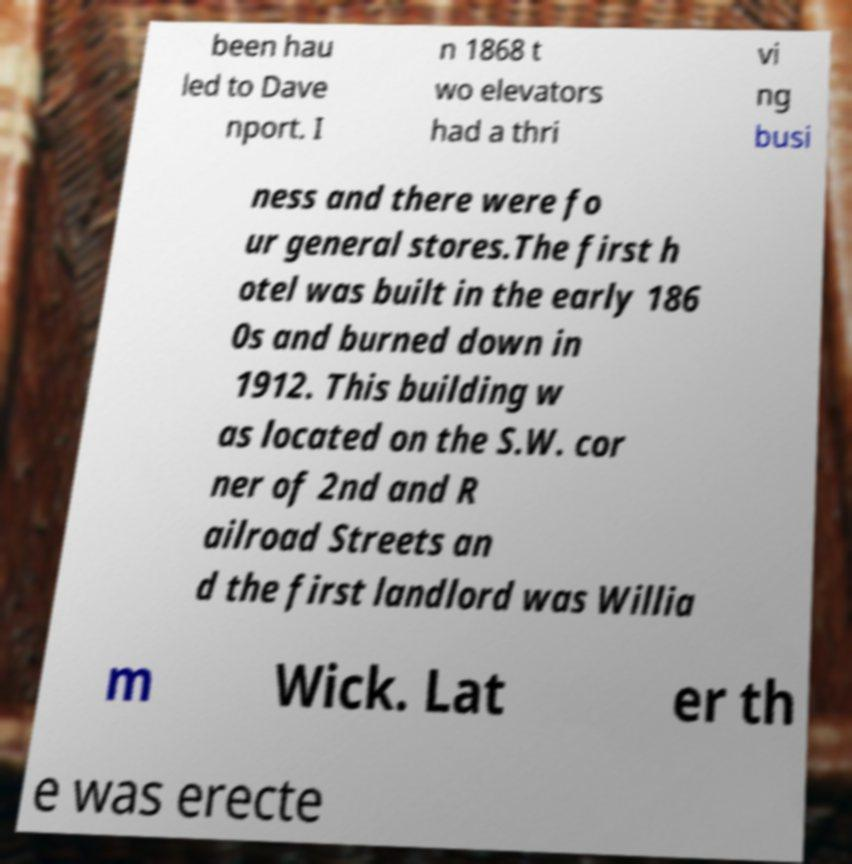There's text embedded in this image that I need extracted. Can you transcribe it verbatim? been hau led to Dave nport. I n 1868 t wo elevators had a thri vi ng busi ness and there were fo ur general stores.The first h otel was built in the early 186 0s and burned down in 1912. This building w as located on the S.W. cor ner of 2nd and R ailroad Streets an d the first landlord was Willia m Wick. Lat er th e was erecte 